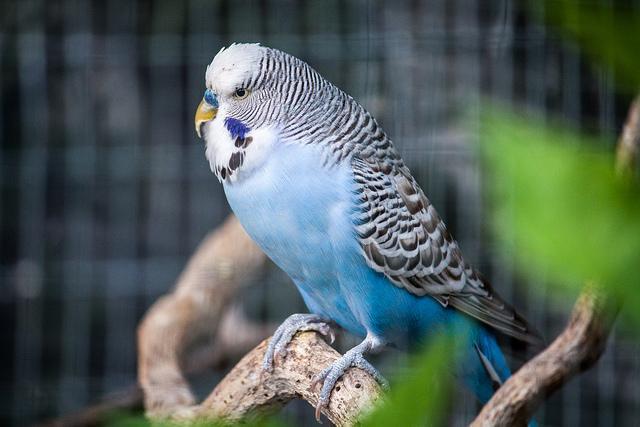How many cows are outside?
Give a very brief answer. 0. 